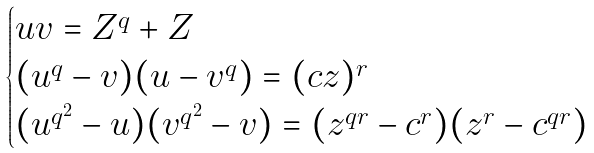Convert formula to latex. <formula><loc_0><loc_0><loc_500><loc_500>\begin{cases} u v = Z ^ { q } + Z \\ ( u ^ { q } - v ) ( u - v ^ { q } ) = ( c z ) ^ { r } \\ ( u ^ { q ^ { 2 } } - u ) ( v ^ { q ^ { 2 } } - v ) = ( z ^ { q r } - c ^ { r } ) ( z ^ { r } - c ^ { q r } ) \end{cases}</formula> 